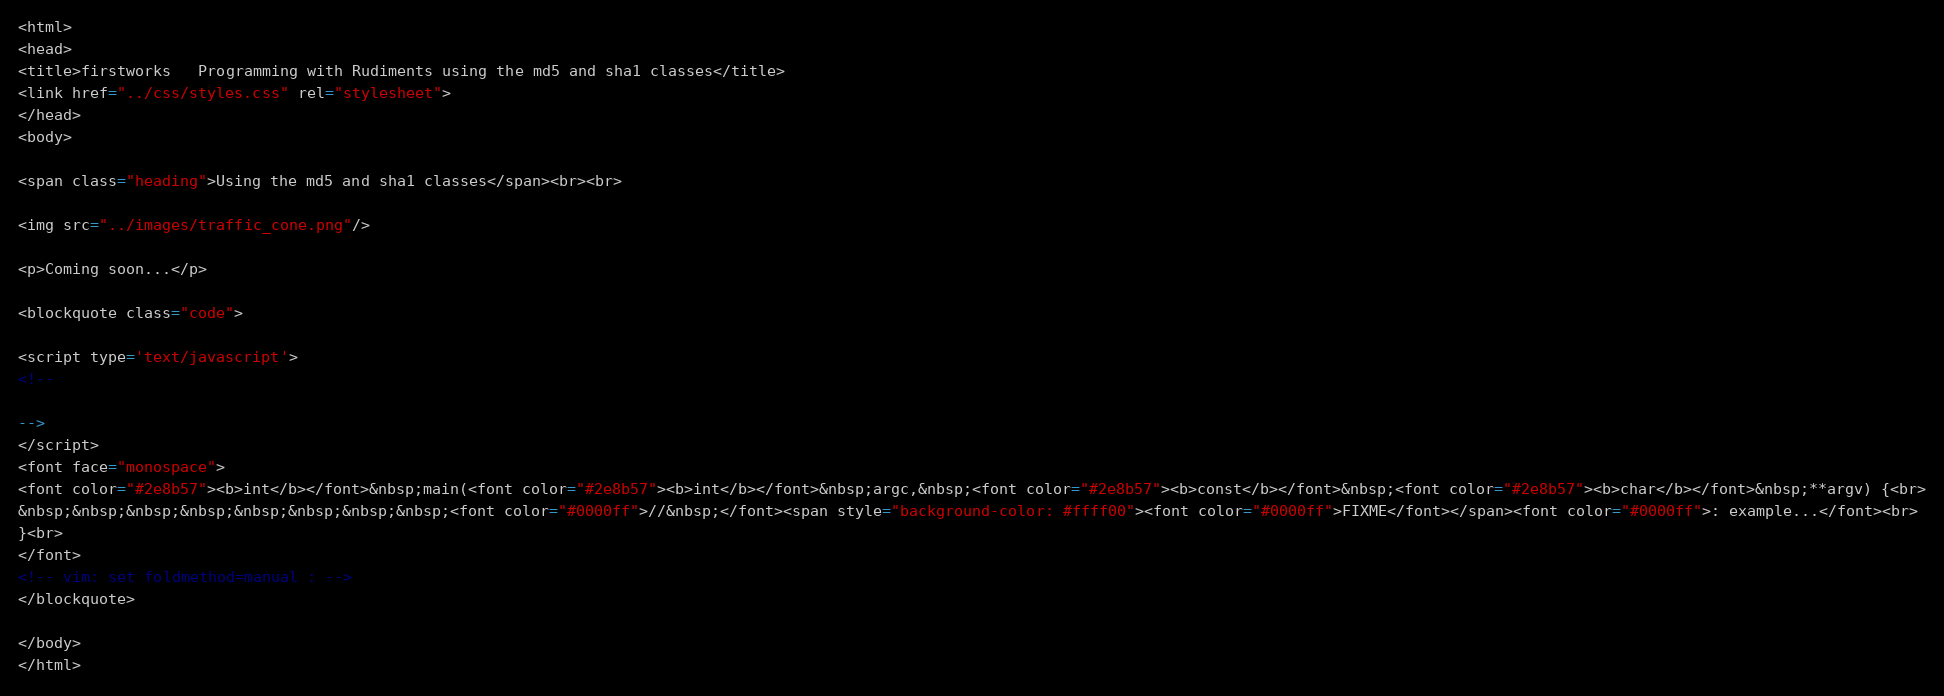Convert code to text. <code><loc_0><loc_0><loc_500><loc_500><_HTML_><html>
<head>
<title>firstworks   Programming with Rudiments using the md5 and sha1 classes</title>
<link href="../css/styles.css" rel="stylesheet">
</head>
<body>

<span class="heading">Using the md5 and sha1 classes</span><br><br>

<img src="../images/traffic_cone.png"/>

<p>Coming soon...</p>

<blockquote class="code">

<script type='text/javascript'>
<!--

-->
</script>
<font face="monospace">
<font color="#2e8b57"><b>int</b></font>&nbsp;main(<font color="#2e8b57"><b>int</b></font>&nbsp;argc,&nbsp;<font color="#2e8b57"><b>const</b></font>&nbsp;<font color="#2e8b57"><b>char</b></font>&nbsp;**argv) {<br>
&nbsp;&nbsp;&nbsp;&nbsp;&nbsp;&nbsp;&nbsp;&nbsp;<font color="#0000ff">//&nbsp;</font><span style="background-color: #ffff00"><font color="#0000ff">FIXME</font></span><font color="#0000ff">: example...</font><br>
}<br>
</font>
<!-- vim: set foldmethod=manual : -->
</blockquote>

</body>
</html>
</code> 